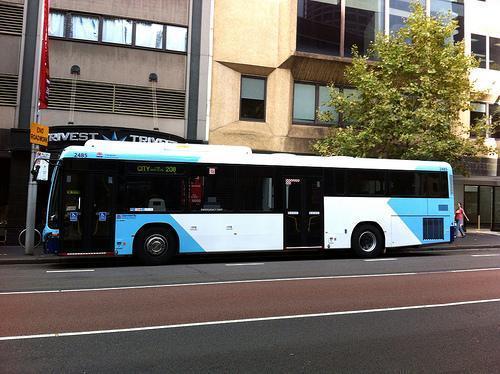How many buses are shown?
Give a very brief answer. 1. 